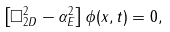<formula> <loc_0><loc_0><loc_500><loc_500>\left [ \square ^ { 2 } _ { 2 D } - \alpha _ { E } ^ { 2 } \right ] \phi ( x , t ) = 0 ,</formula> 